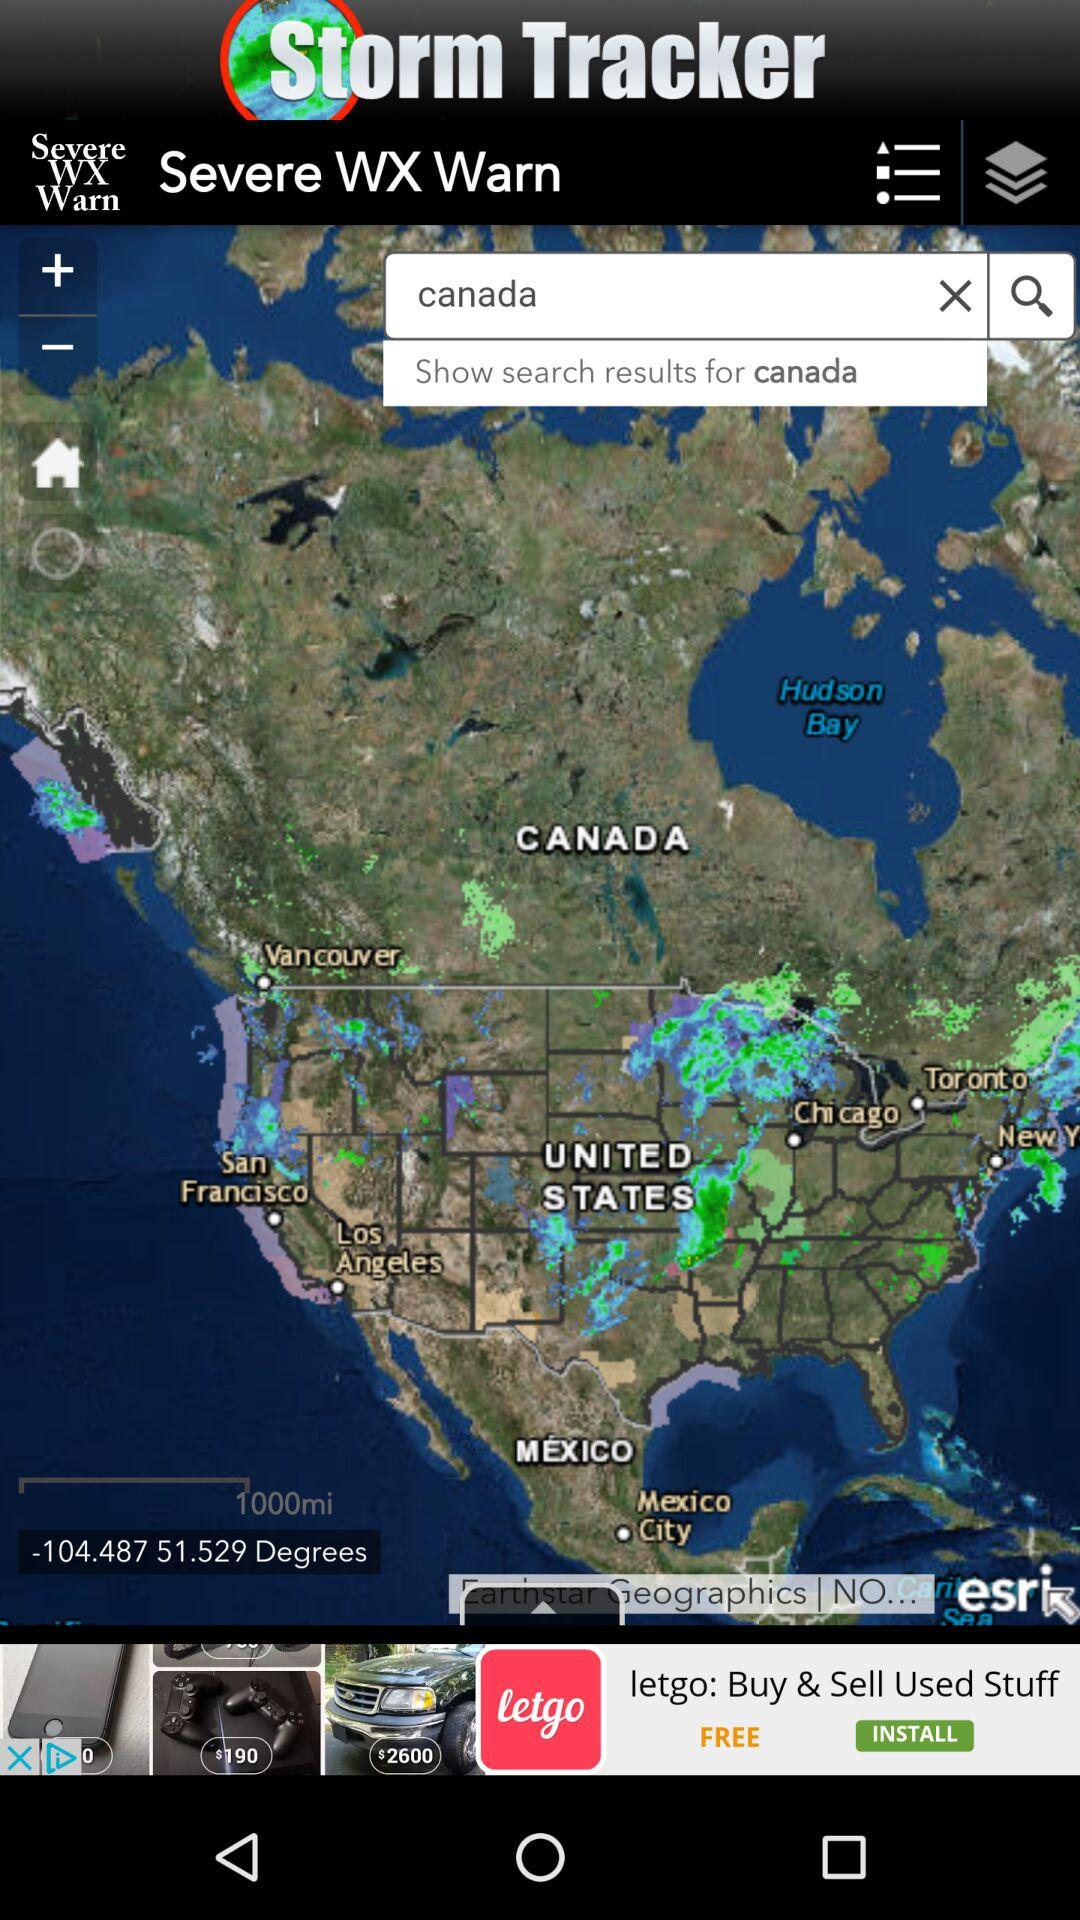What is the entered country? The entered country is Canada. 